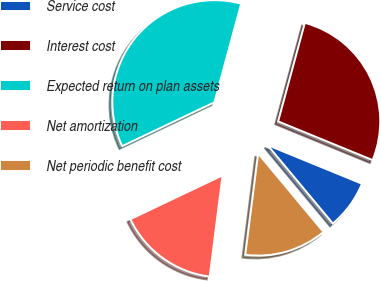Convert chart to OTSL. <chart><loc_0><loc_0><loc_500><loc_500><pie_chart><fcel>Service cost<fcel>Interest cost<fcel>Expected return on plan assets<fcel>Net amortization<fcel>Net periodic benefit cost<nl><fcel>7.76%<fcel>26.97%<fcel>36.28%<fcel>15.92%<fcel>13.07%<nl></chart> 